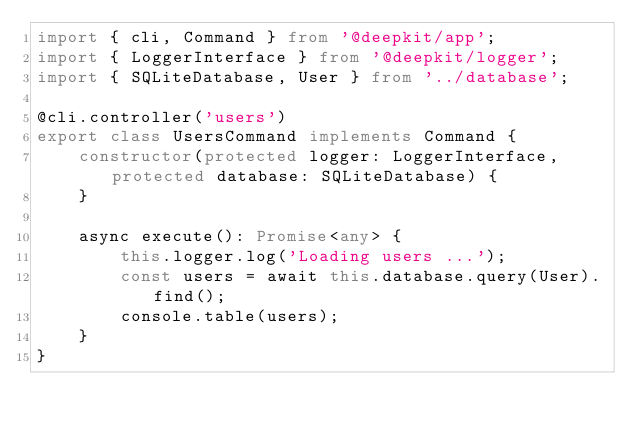Convert code to text. <code><loc_0><loc_0><loc_500><loc_500><_TypeScript_>import { cli, Command } from '@deepkit/app';
import { LoggerInterface } from '@deepkit/logger';
import { SQLiteDatabase, User } from '../database';

@cli.controller('users')
export class UsersCommand implements Command {
    constructor(protected logger: LoggerInterface, protected database: SQLiteDatabase) {
    }

    async execute(): Promise<any> {
        this.logger.log('Loading users ...');
        const users = await this.database.query(User).find();
        console.table(users);
    }
}
</code> 